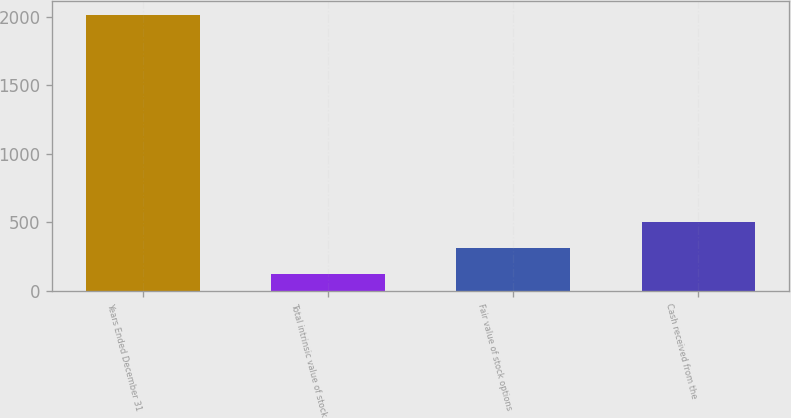<chart> <loc_0><loc_0><loc_500><loc_500><bar_chart><fcel>Years Ended December 31<fcel>Total intrinsic value of stock<fcel>Fair value of stock options<fcel>Cash received from the<nl><fcel>2011<fcel>125<fcel>313.6<fcel>502.2<nl></chart> 